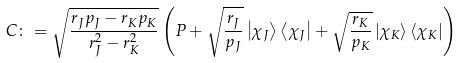Convert formula to latex. <formula><loc_0><loc_0><loc_500><loc_500>C \colon = \sqrt { \frac { r _ { J } p _ { J } - r _ { K } p _ { K } } { r ^ { 2 } _ { J } - r ^ { 2 } _ { K } } } \left ( P + \sqrt { \frac { r _ { J } } { p _ { J } } } \left | \chi _ { J } \right \rangle \left \langle \chi _ { J } \right | + \sqrt { \frac { r _ { K } } { p _ { K } } } \left | \chi _ { K } \right \rangle \left \langle \chi _ { K } \right | \right )</formula> 